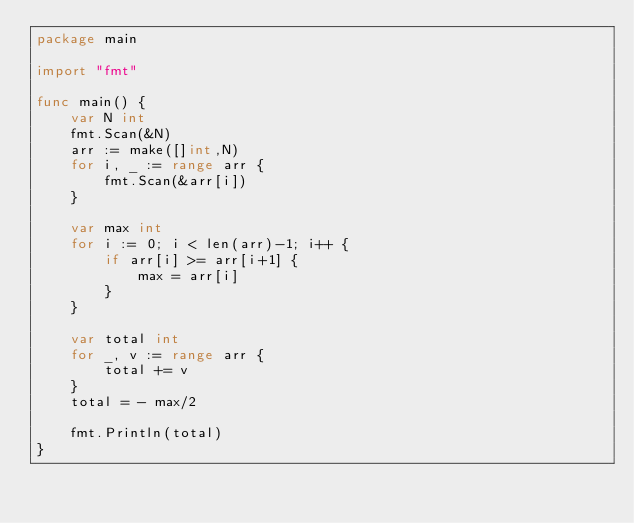<code> <loc_0><loc_0><loc_500><loc_500><_Go_>package main

import "fmt"

func main() {
	var N int
	fmt.Scan(&N)
	arr := make([]int,N)
	for i, _ := range arr {
		fmt.Scan(&arr[i])
	}

	var max int
	for i := 0; i < len(arr)-1; i++ {
		if arr[i] >= arr[i+1] {
			max = arr[i]
		}
	}

	var total int 
	for _, v := range arr {
		total += v
	}
	total = - max/2

	fmt.Println(total)
}
</code> 